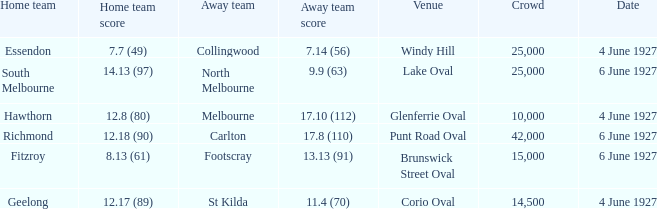How many people in the crowd with north melbourne as an away team? 25000.0. 